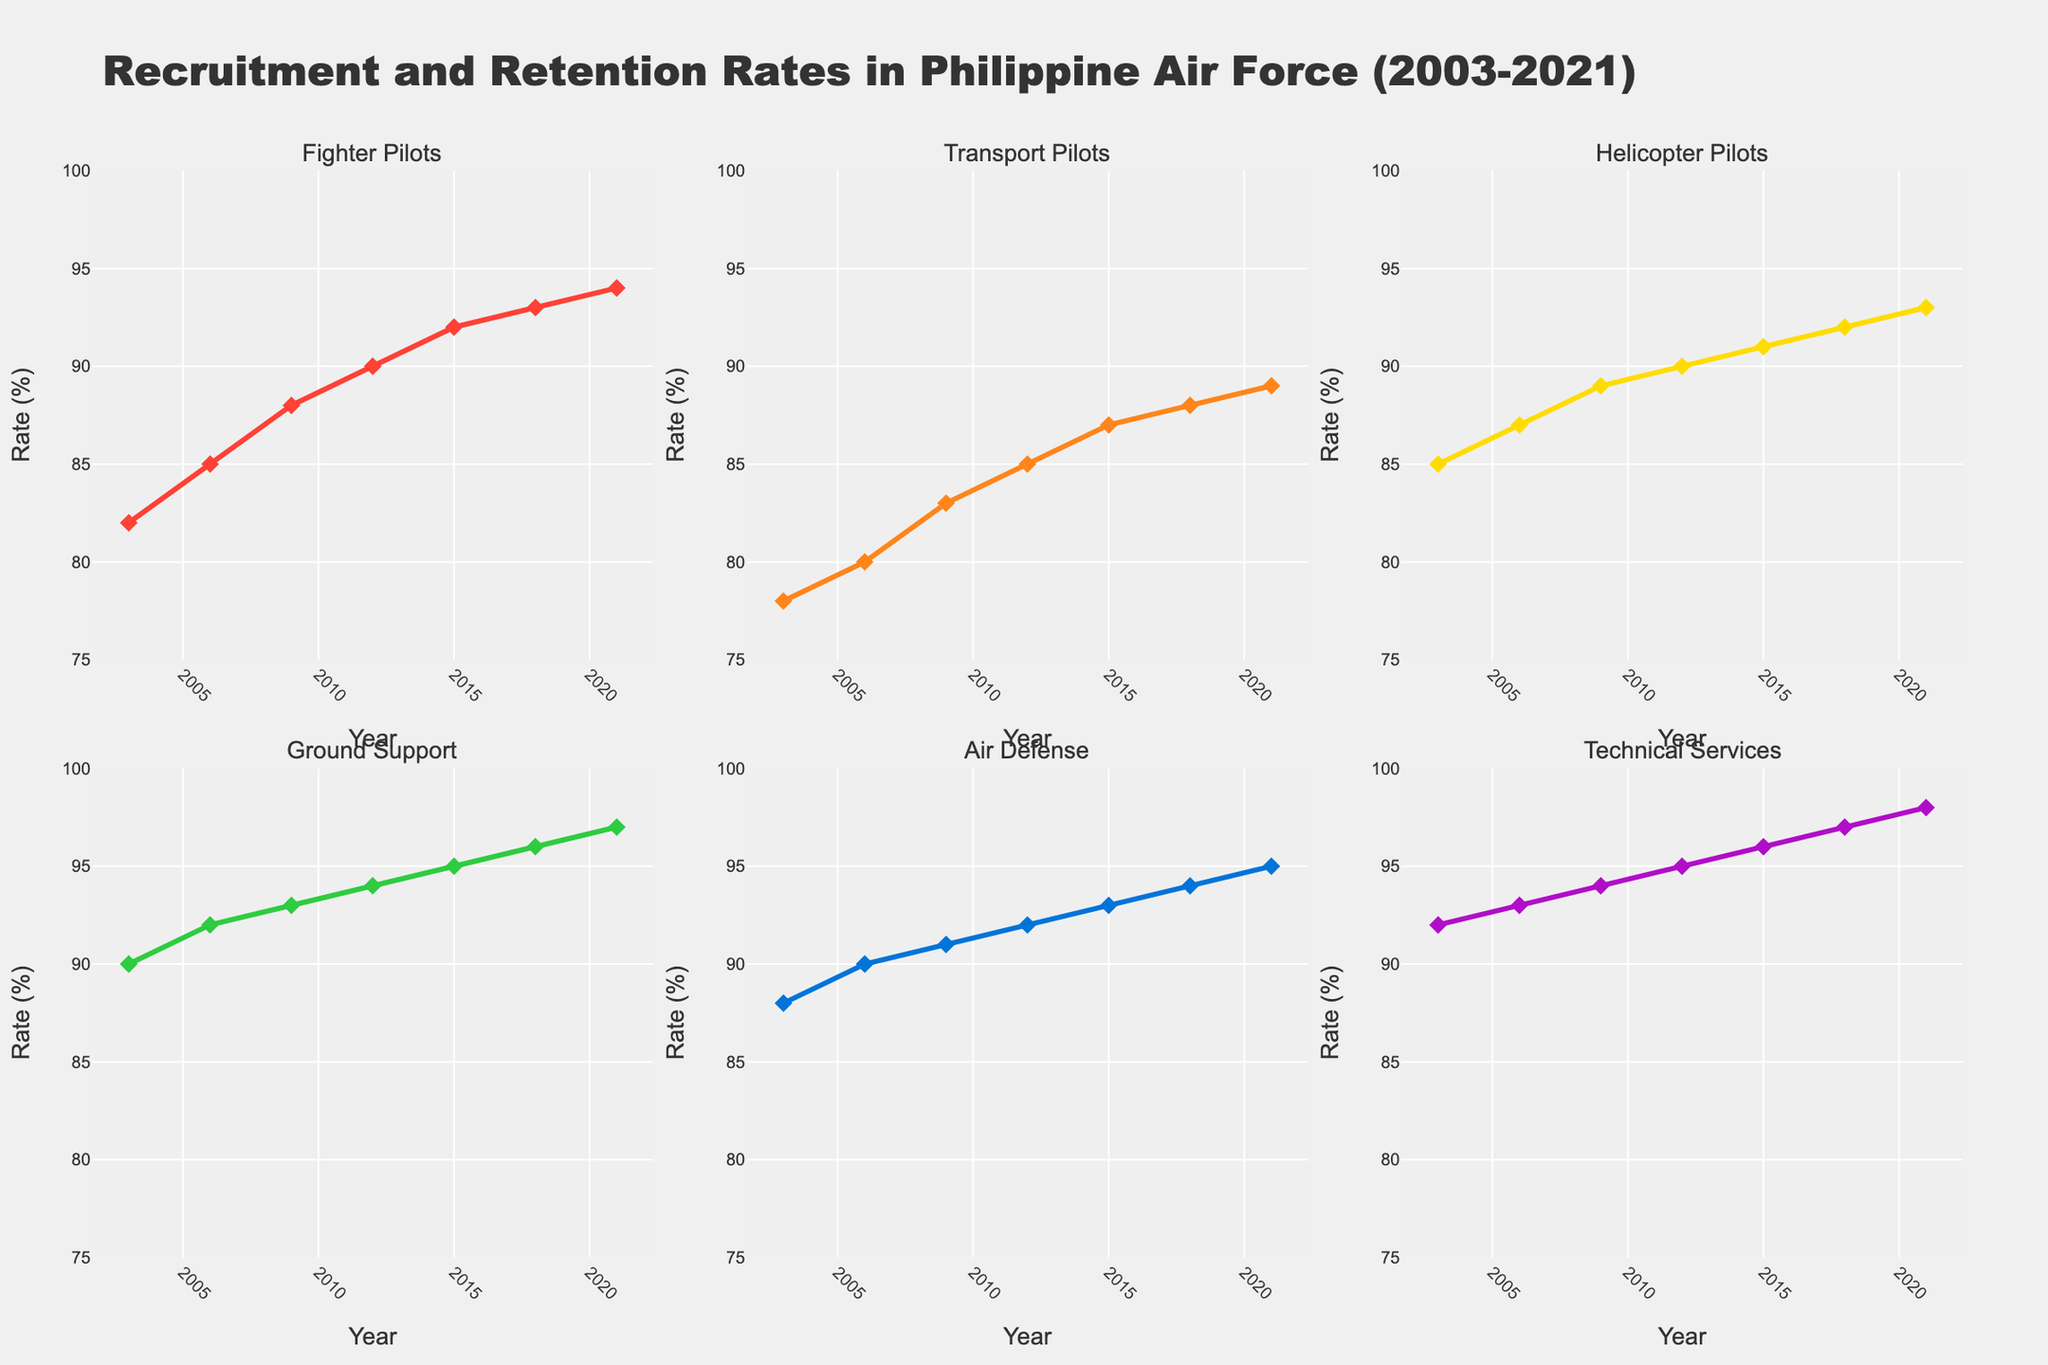what is the main title of the figure? The main title of the figure is shown at the top of the chart. It is displayed in a large, bold font for easy visibility. The main title in this case reads "Recruitment and Retention Rates in Philippine Air Force (2003-2021)"
Answer: Recruitment and Retention Rates in Philippine Air Force (2003-2021) How many subplots are there in the figure? There are six service branches displayed as individual subplots in a 2x3 grid formation, each representing a different service branch: Fighter Pilots, Transport Pilots, Helicopter Pilots, Ground Support, Air Defense, and Technical Services.
Answer: 6 Which service branch shows the highest retention rate in 2021? By examining the subplots, the retention rate for each branch in 2021 is visible. The subplot for Technical Services shows the highest retention rate at 98% in 2021.
Answer: Technical Services What is the overall trend for Fighter Pilots' rates from 2003 to 2021? Observing the line chart for Fighter Pilots across the years shows an upward trend. Starting at 82% in 2003, the retention rate experiences a steady increase, reaching 94% in 2021.
Answer: Increasing Compare the retention rates of Helicopter Pilots and Ground Support in 2015. Which one is higher? In the 2015 subplots, the retention rate for Helicopter Pilots is 91%, whereas Ground Support has a rate of 95%. Ground Support has the higher retention rate between the two.
Answer: Ground Support What is the average retention rate for Air Defense over the entire period (2003-2021)? The retention rates for Air Defense over the years are: 88%, 90%, 91%, 92%, 93%, 94%, and 95%. Calculating the average: (88 + 90 + 91 + 92 + 93 + 94 + 95)/7 = 91.86%.
Answer: 91.86% Which years show the retention rates for Technical Services being higher than 95%? By examining the subplot for Technical Services, we see that retention rates higher than 95% occur in the years 2018 (97%) and 2021 (98%).
Answer: 2018, 2021 Has there been any year when the Transport Pilots' retention rate was lower than the Fighter Pilots'? If so, which year(s)? Looking at the Transport Pilots and Fighter Pilots subplots, in 2003, Transport Pilots had a retention rate of 78%, which is lower than Fighter Pilots' rate of 82% that year.
Answer: 2003 What is the range of retention rates for Ground Support from 2003 to 2021? The retention rates for Ground Support over the years range from a minimum of 90% in 2003 to a maximum of 97% in 2021. Therefore, the range is from 90% to 97%.
Answer: 90-97% 